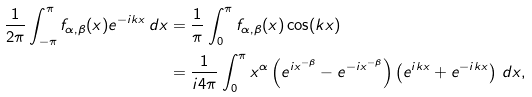<formula> <loc_0><loc_0><loc_500><loc_500>\frac { 1 } { 2 \pi } \int _ { - \pi } ^ { \pi } f _ { \alpha , \beta } ( x ) e ^ { - i k x } \, d x & = \frac { 1 } { \pi } \int _ { 0 } ^ { \pi } f _ { \alpha , \beta } ( x ) \cos ( k x ) \\ & = \frac { 1 } { i 4 \pi } \int _ { 0 } ^ { \pi } x ^ { \alpha } \left ( e ^ { i x ^ { - \beta } } - e ^ { - i x ^ { - \beta } } \right ) \left ( e ^ { i k x } + e ^ { - i k x } \right ) \, d x ,</formula> 